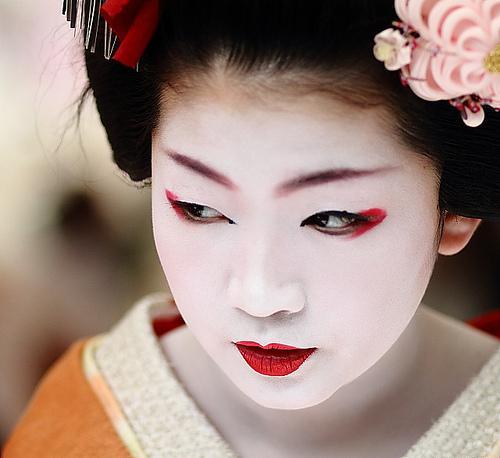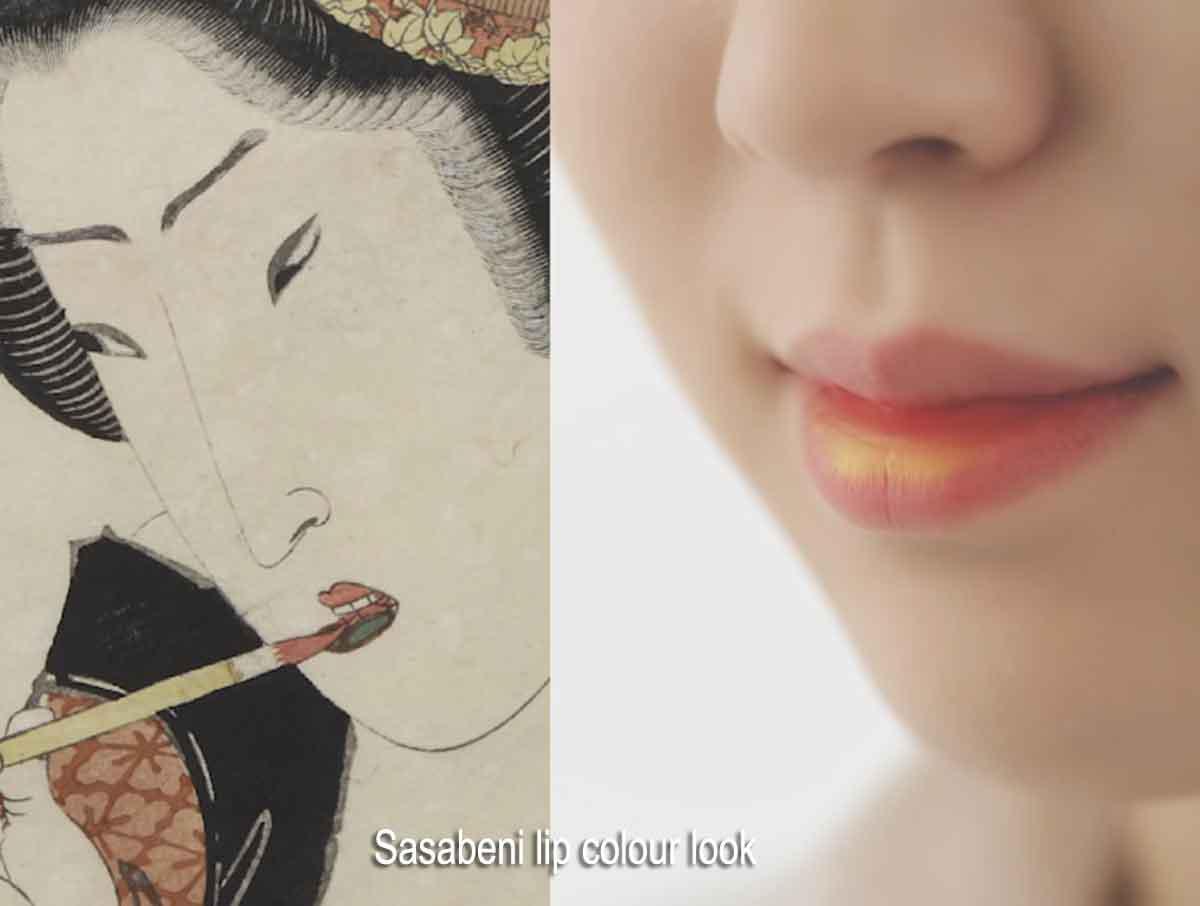The first image is the image on the left, the second image is the image on the right. Analyze the images presented: Is the assertion "An image shows a woman in pale geisha makeup, with pink flowers in her upswept hair." valid? Answer yes or no. Yes. The first image is the image on the left, the second image is the image on the right. Analyze the images presented: Is the assertion "A geisha is wearing large flowers on her hair and is not looking at the camera." valid? Answer yes or no. Yes. 